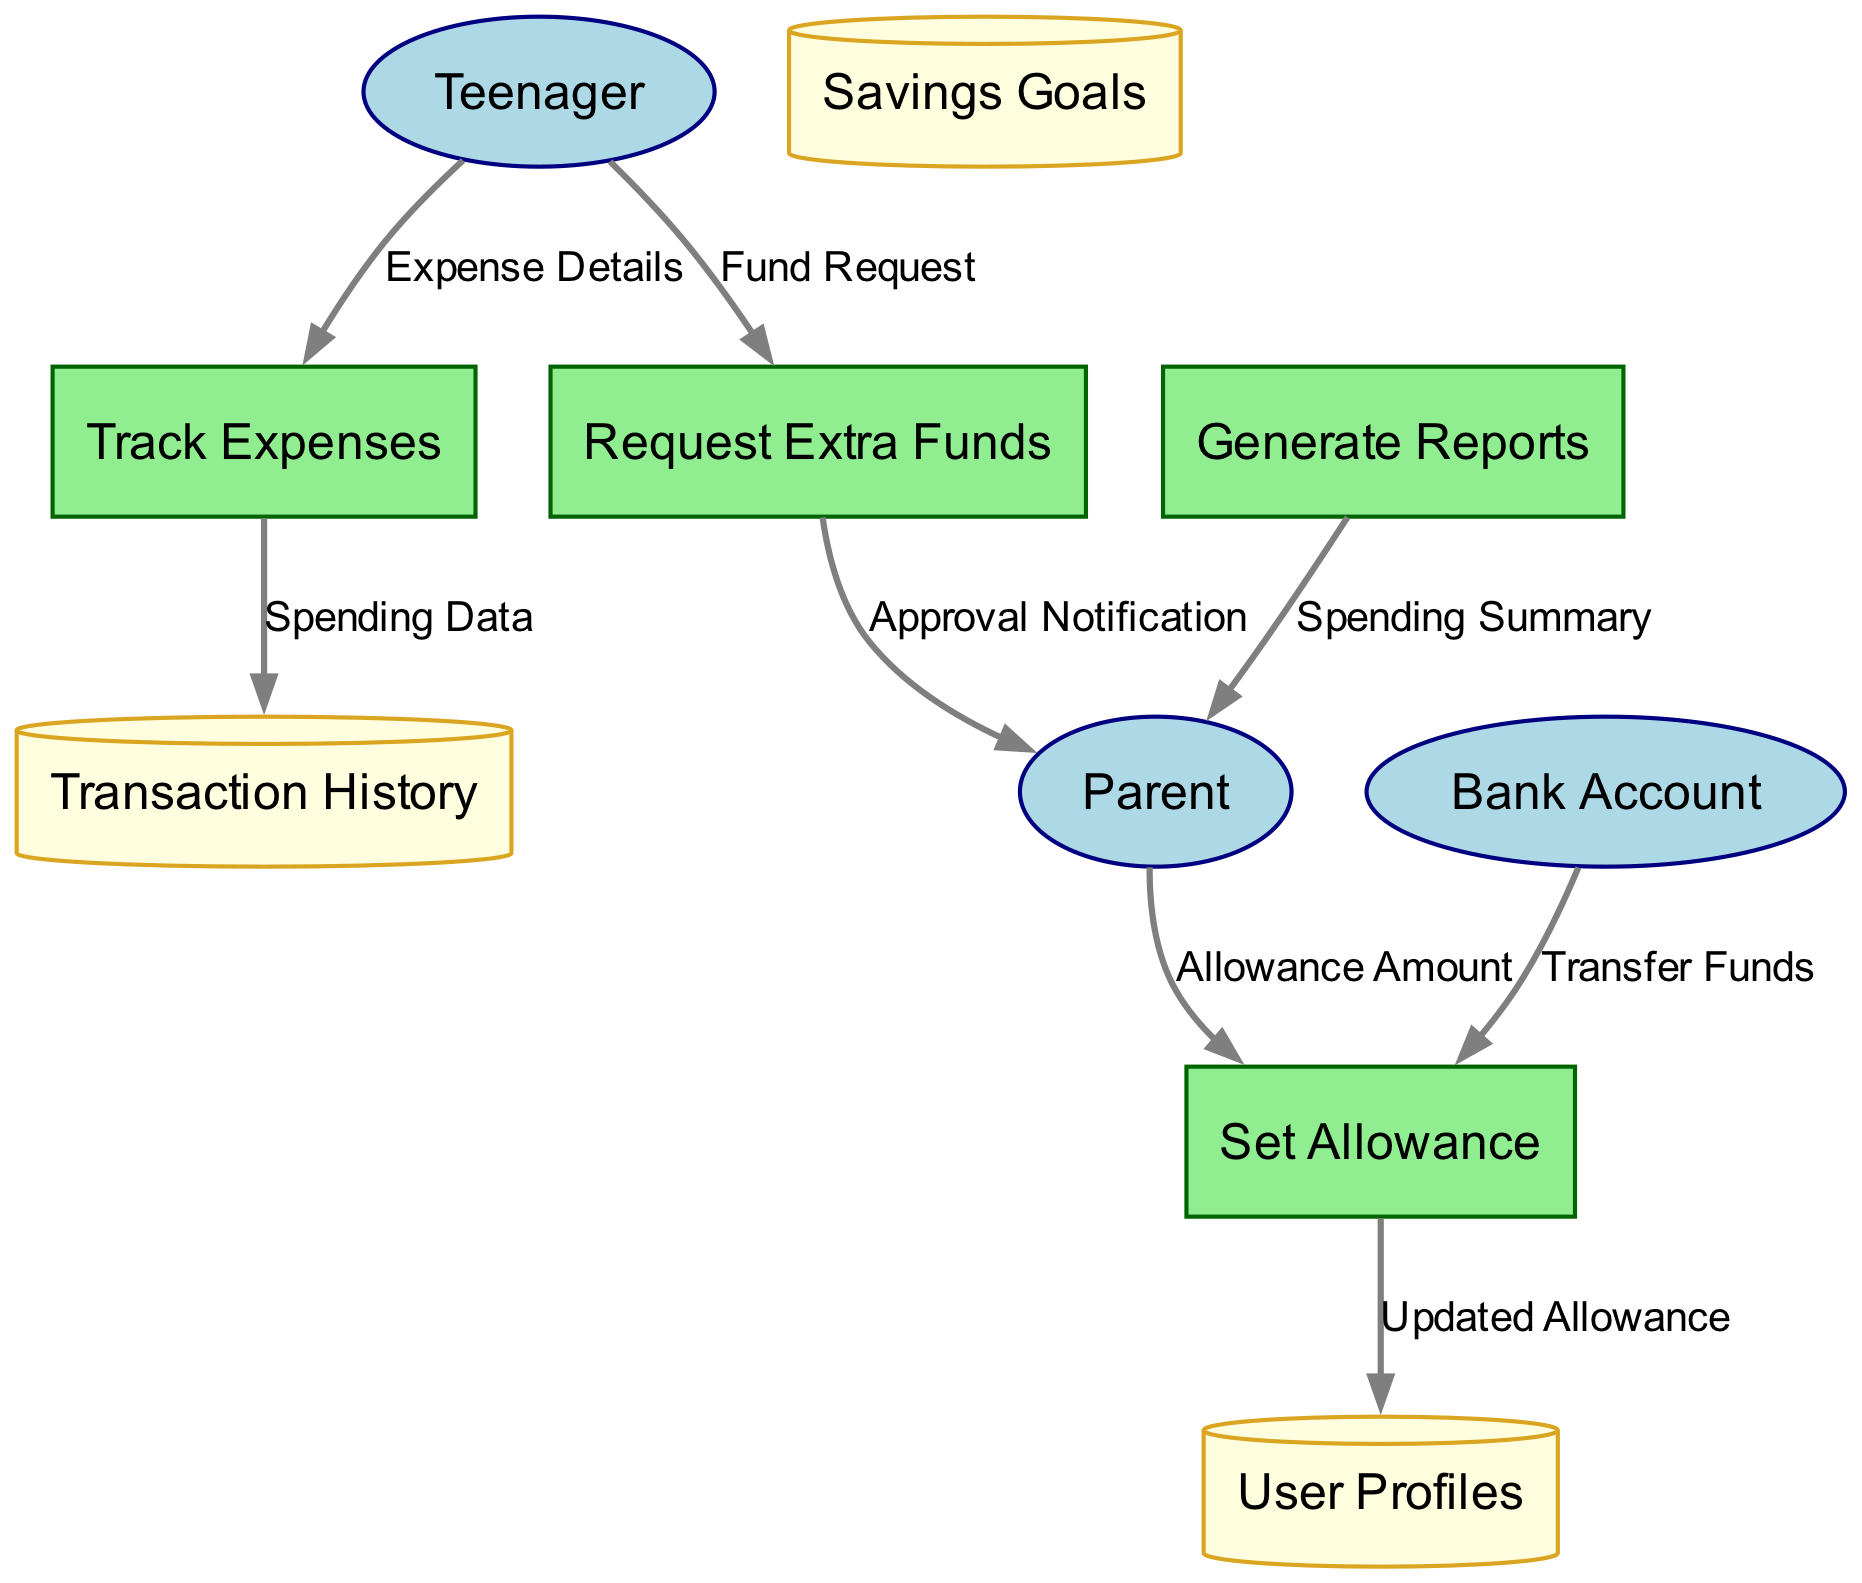What are the external entities in this diagram? The external entities listed in the diagram are Teenager, Parent, and Bank Account. These are the sources or destinations of data flows in the diagram.
Answer: Teenager, Parent, Bank Account How many processes are in the diagram? The diagram includes four processes: Set Allowance, Track Expenses, Request Extra Funds, and Generate Reports. This can be determined by counting the rectangles labeled as processes.
Answer: 4 What is the data flow from Teenager to Track Expenses labeled as? The flow from Teenager to Track Expenses is labeled as "Expense Details." This can be identified by following the arrow connecting Teenager to Track Expenses and reading the label.
Answer: Expense Details Which process receives data from the Bank Account? The process that receives data from the Bank Account is "Set Allowance." This can be confirmed by tracing the flow from Bank Account to Set Allowance.
Answer: Set Allowance What data store receives updated allowance information? The data store that receives updated allowance information is User Profiles. This is seen in the data flow from Set Allowance to User Profiles, indicating that the allowance changes are stored there.
Answer: User Profiles From which process does the Parent receive the Spending Summary? The Parent receives the Spending Summary from the "Generate Reports" process. This is evident from the arrow leading from Generate Reports to Parent, detailing this specific output.
Answer: Generate Reports What type of flow does the Fund Request represent? The Fund Request represents the type of flow from the Teenager to the Request Extra Funds process; this is identified by tracing the arrow labeled Fund Request in the diagram.
Answer: Fund Request How many data stores are present in the diagram? There are three data stores present in the diagram: User Profiles, Transaction History, and Savings Goals. This can be verified by counting the cylindrical shapes labeled as data stores.
Answer: 3 What does the Approval Notification flow from Request Extra Funds to Parent signify? The Approval Notification signifies that after a Fund Request is made, there is a communication back to the Parent about the approval status of that request. This shows a feedback mechanism in the flow of information.
Answer: Approval Notification 